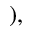<formula> <loc_0><loc_0><loc_500><loc_500>) ,</formula> 